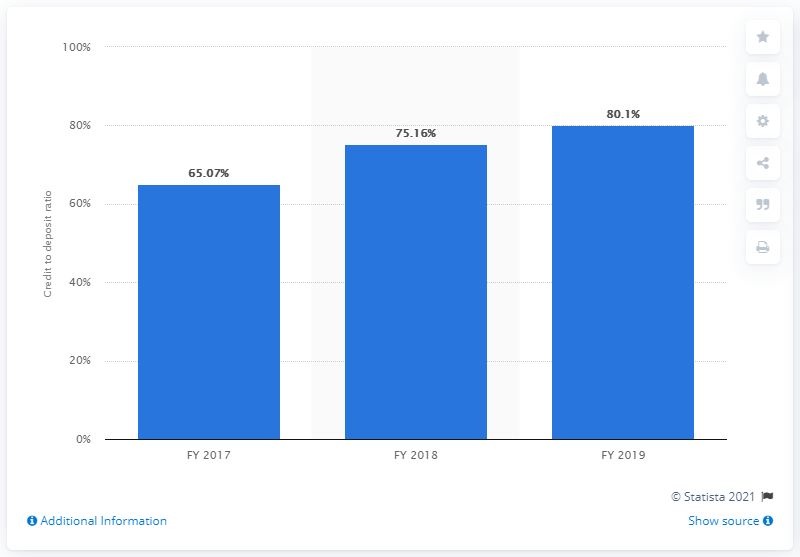Mention a couple of crucial points in this snapshot. In the fiscal year 2019, the credit to deposit ratio of Karnataka Bank in India was 80.1%. 